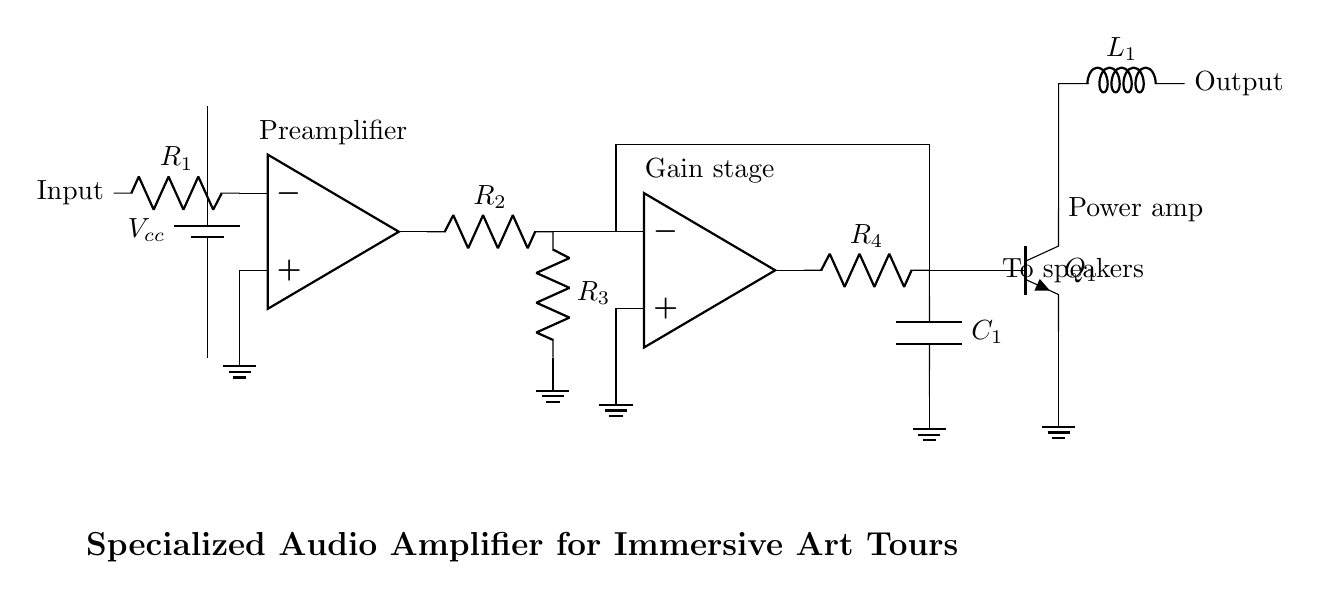What is the type of circuit shown? The circuit is an audio amplifier circuit, which uses operational amplifiers for signal processing and enhancement.
Answer: audio amplifier What is the role of R1 in this circuit? R1 serves as a feedback resistor connected to the inverting input of the first operational amplifier, controlling gain and input impedance.
Answer: feedback resistor How many operational amplifiers are present? There are two operational amplifiers utilized in this circuit for signal amplification.
Answer: two What component converts the output signal to sound? The component responsible for converting the electrical audio signal to sound is the speaker, which is connected to the output of the amplifier.
Answer: speakers What is the purpose of the feedback loop in this amplifier? The feedback loop stabilizes the gain of the amplifier by providing a portion of the output back to the inverting input, which improves linearity and reduces distortion.
Answer: stabilize gain How does the power amplifier enhance the signal? The power amplifier, implemented with the transistor Q1, boosts the current and power level of the audio signal, allowing it to drive the speakers effectively.
Answer: boosts current Which component is responsible for coupling signals to the output? The capacitor C1 is used for coupling the amplified signals to the speakers while blocking DC components, ensuring only AC audio signals pass through.
Answer: capacitor 